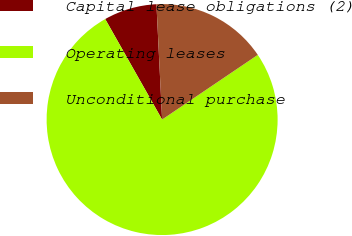Convert chart to OTSL. <chart><loc_0><loc_0><loc_500><loc_500><pie_chart><fcel>Capital lease obligations (2)<fcel>Operating leases<fcel>Unconditional purchase<nl><fcel>7.42%<fcel>76.26%<fcel>16.32%<nl></chart> 